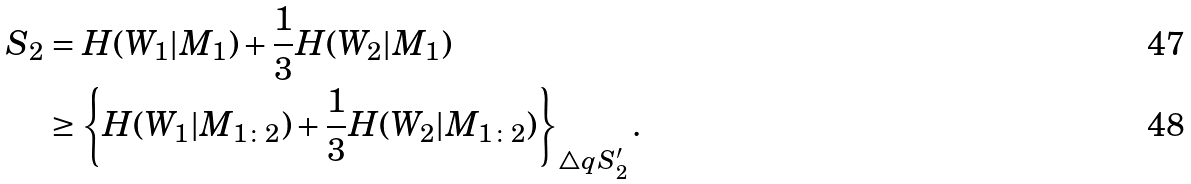<formula> <loc_0><loc_0><loc_500><loc_500>S _ { 2 } & = H ( W _ { 1 } | M _ { 1 } ) + \frac { 1 } { 3 } H ( W _ { 2 } | M _ { 1 } ) \\ & \geq \left \{ H ( W _ { 1 } | M _ { 1 \colon 2 } ) + \frac { 1 } { 3 } H ( W _ { 2 } | M _ { 1 \colon 2 } ) \right \} _ { \triangle q S _ { 2 } ^ { \prime } } .</formula> 